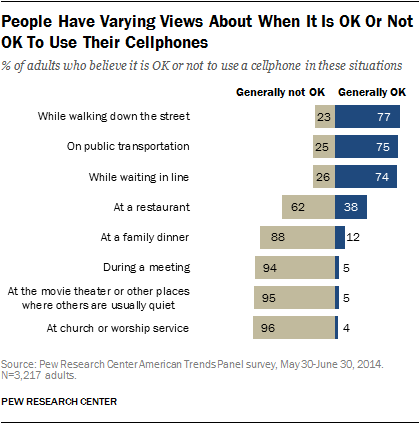Identify some key points in this picture. The difference between the highest value of the grey bar and the lowest value of the blue bar is 92. The value represented by the blue bar is generally considered to be acceptable. 